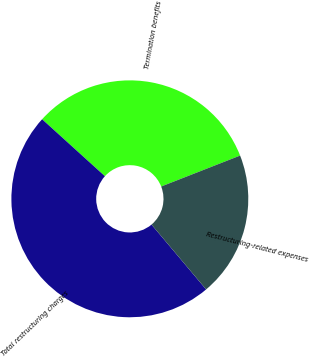Convert chart. <chart><loc_0><loc_0><loc_500><loc_500><pie_chart><fcel>Termination benefits<fcel>Total restructuring charges<fcel>Restructuring-related expenses<nl><fcel>32.33%<fcel>47.86%<fcel>19.81%<nl></chart> 